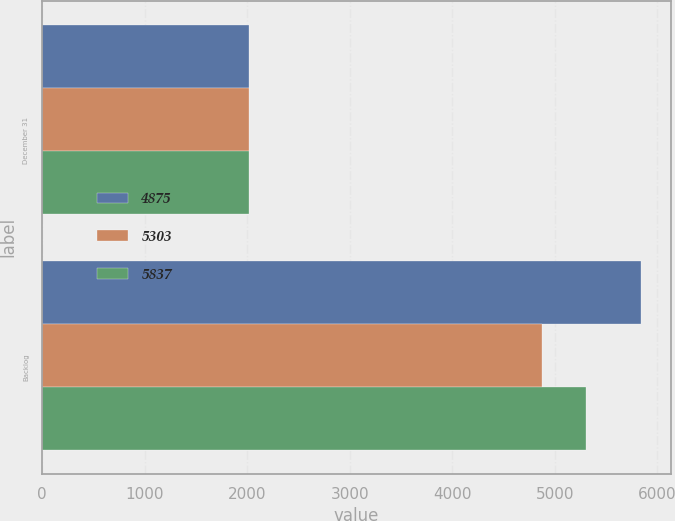Convert chart. <chart><loc_0><loc_0><loc_500><loc_500><stacked_bar_chart><ecel><fcel>December 31<fcel>Backlog<nl><fcel>4875<fcel>2018<fcel>5837<nl><fcel>5303<fcel>2017<fcel>4875<nl><fcel>5837<fcel>2016<fcel>5303<nl></chart> 